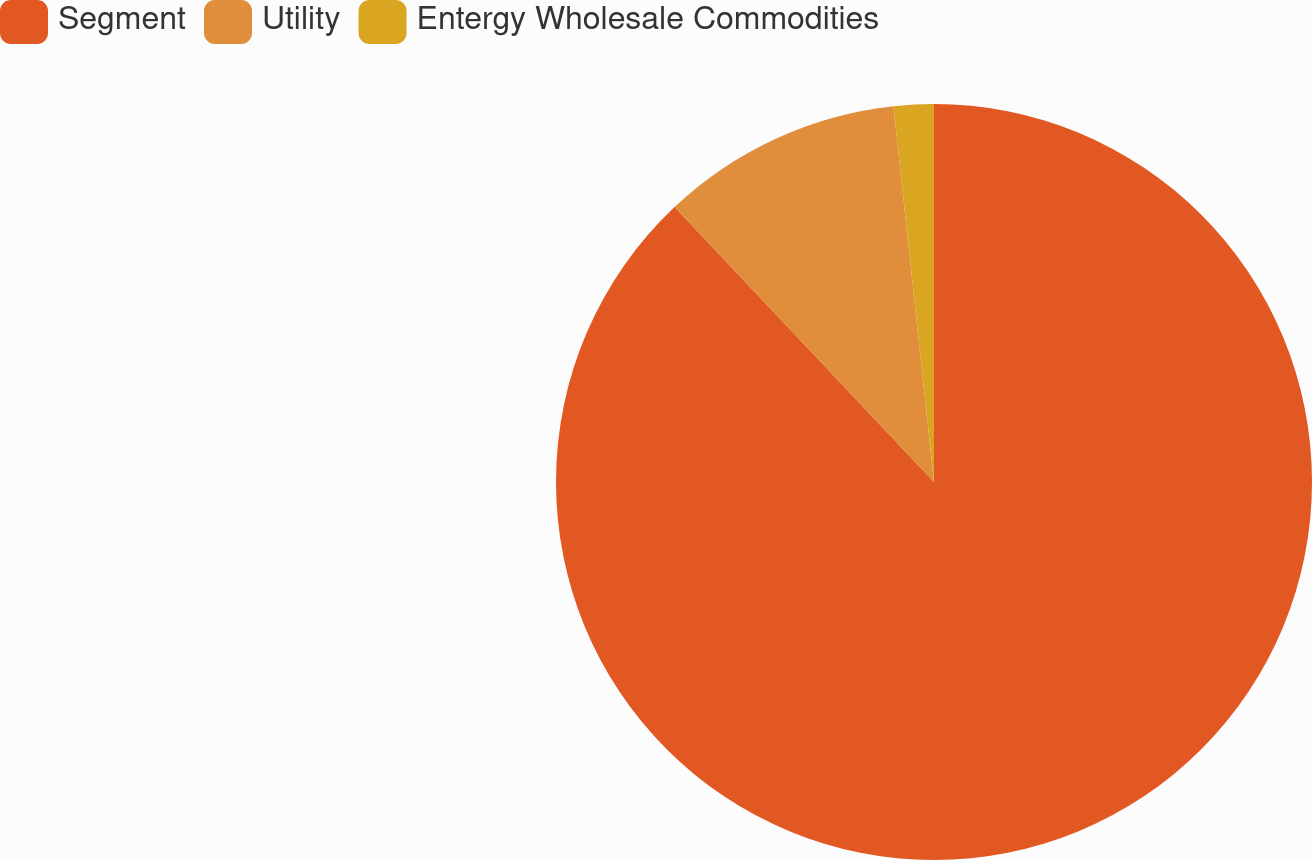Convert chart. <chart><loc_0><loc_0><loc_500><loc_500><pie_chart><fcel>Segment<fcel>Utility<fcel>Entergy Wholesale Commodities<nl><fcel>87.96%<fcel>10.33%<fcel>1.71%<nl></chart> 